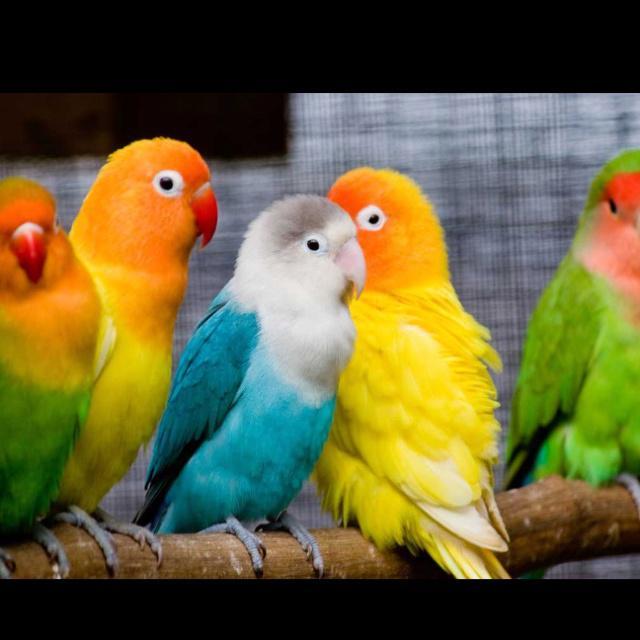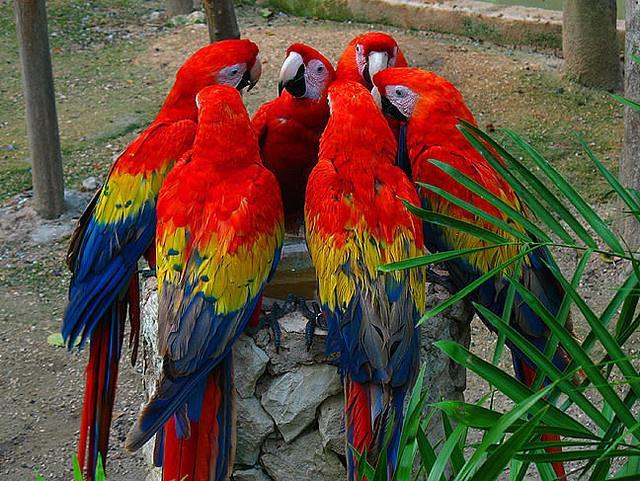The first image is the image on the left, the second image is the image on the right. Evaluate the accuracy of this statement regarding the images: "There are at least 2 blue-headed parrots.". Is it true? Answer yes or no. No. The first image is the image on the left, the second image is the image on the right. Given the left and right images, does the statement "One of the images has only two parrots." hold true? Answer yes or no. No. 